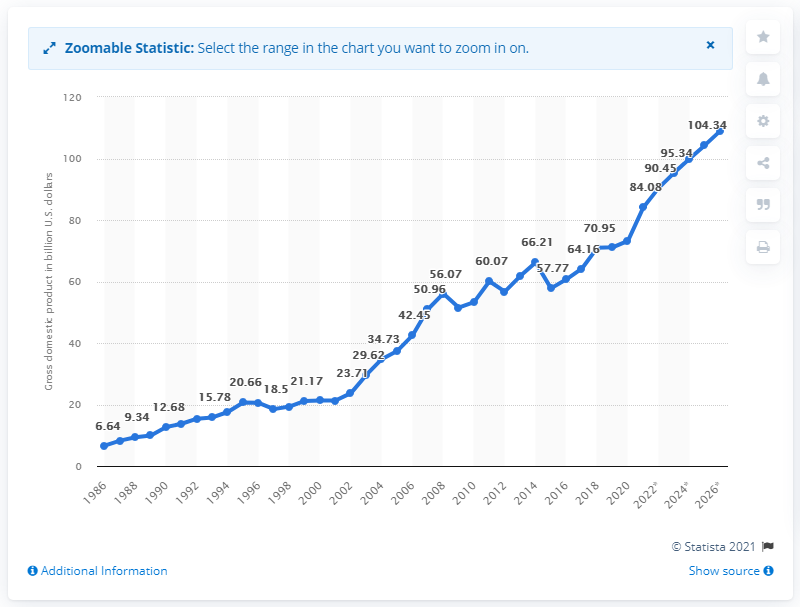Mention a couple of crucial points in this snapshot. The gross domestic product of Luxembourg in 2020 was estimated to be 73.21 billion dollars. 